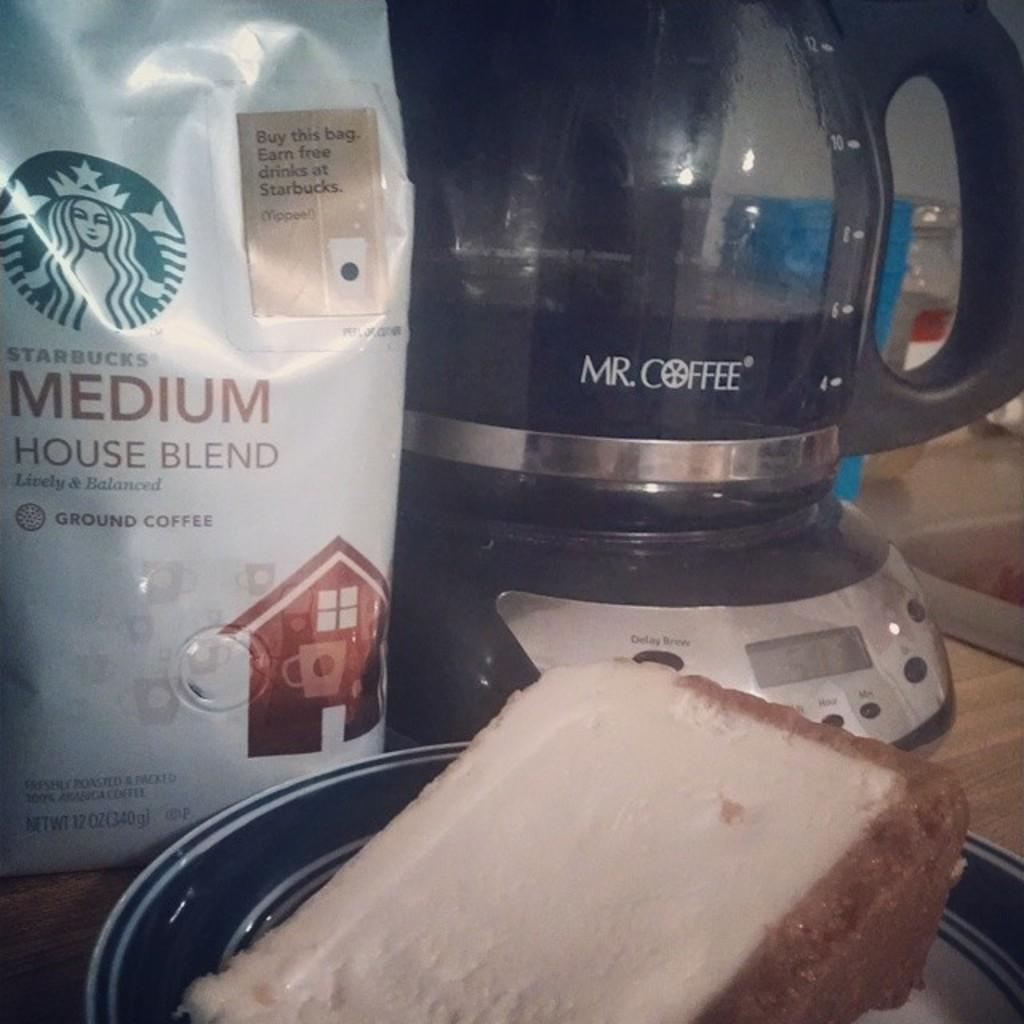<image>
Relay a brief, clear account of the picture shown. a Mr Coffee coffee pot sits beside a bag of starbucks coffee 